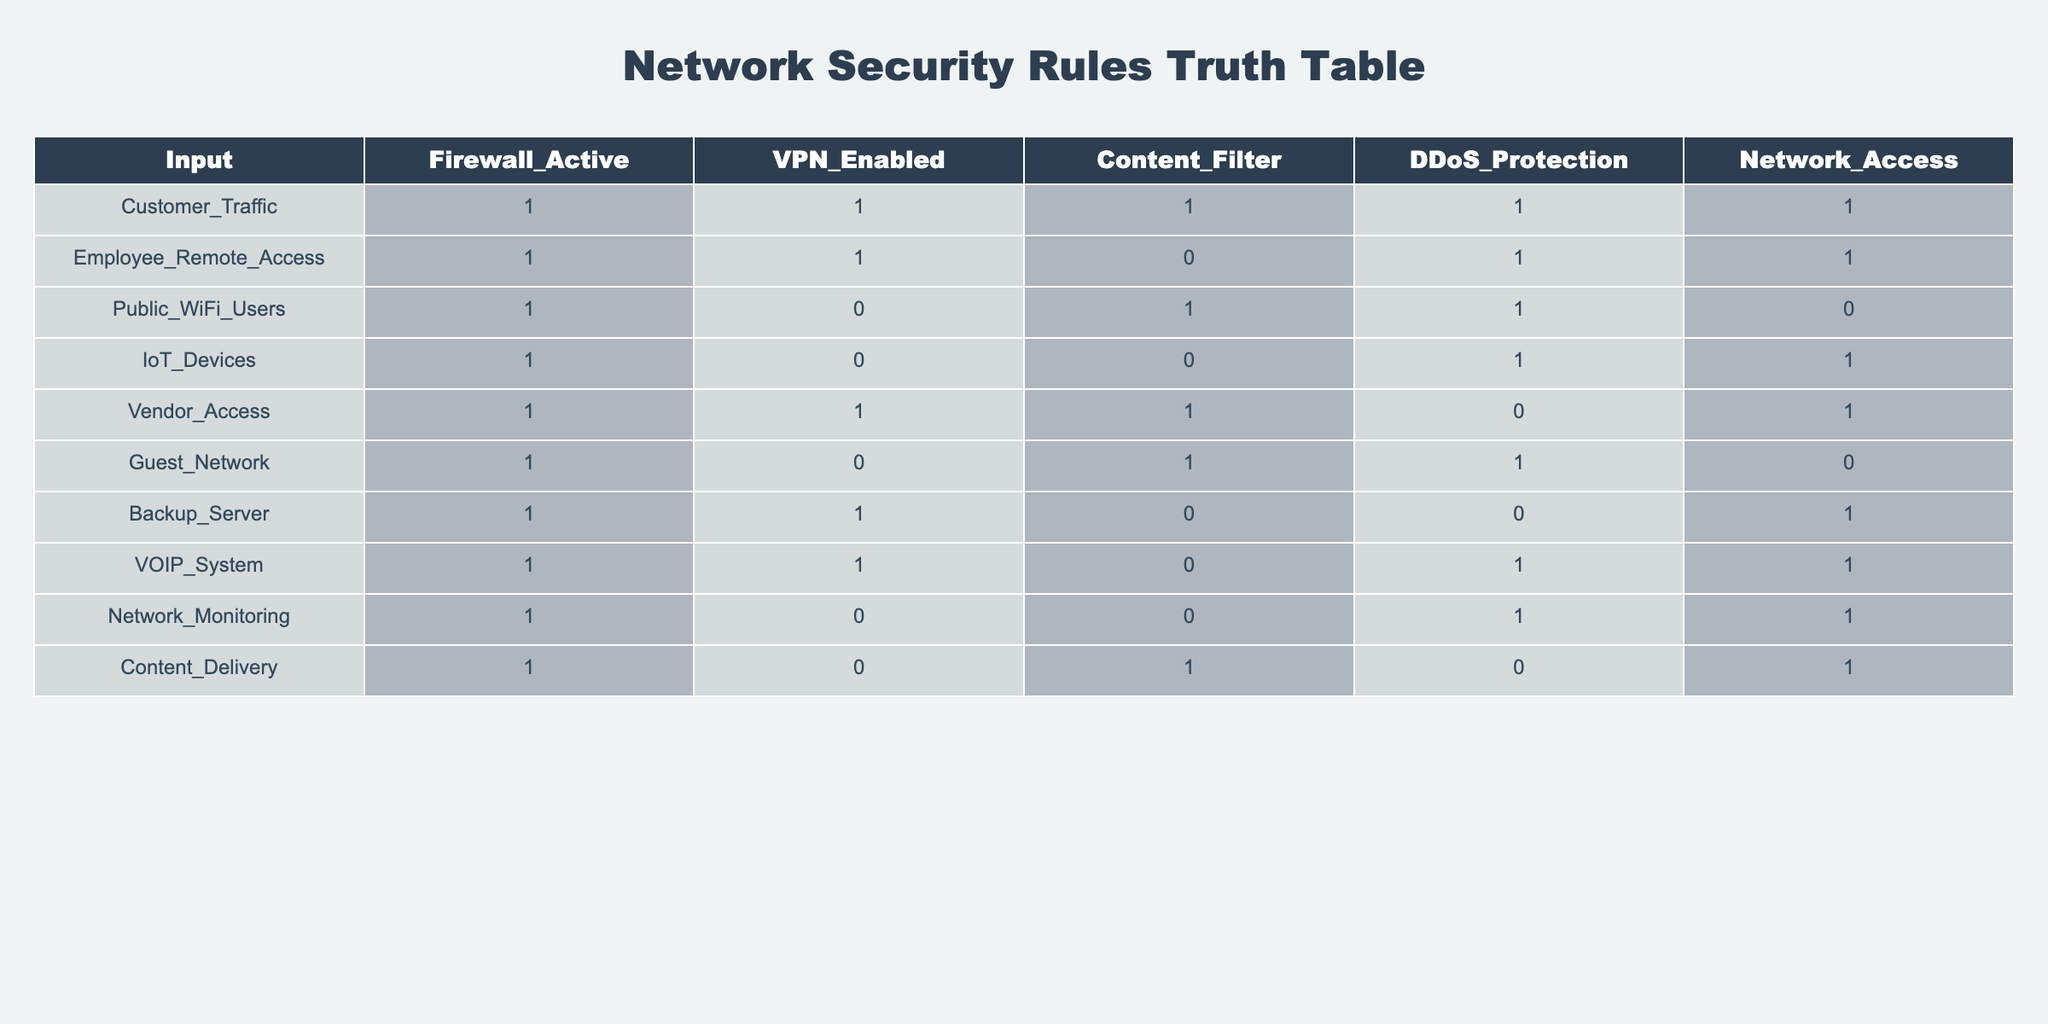What is the status of VPN for Customer Traffic? In the row for Customer Traffic, the value under the VPN_Enabled column is 1, indicating that VPN is enabled for this type of traffic.
Answer: Yes Is DDoS Protection active for IoT Devices? For the row pertaining to IoT Devices, the DDoS_Protection column shows a 1, meaning that DDoS Protection is indeed active for IoT Devices.
Answer: Yes Which category has both VPN and Content Filter enabled? We need to check both the VPN_Enabled and Content_Filter columns for each row. The only row where both are 1 is for Vendor_Access.
Answer: Vendor Access Count how many categories have Network Access disabled. We will look through the Network_Access column and count the occurrences of 0. The relevant rows are Public_WiFi_Users, Guest_Network, and Content_Delivery, giving us a total of 3.
Answer: 3 Is there any category that has Firewall Active but does not have Content Filter enabled? To find this, we check rows with Firewall_Active as 1 and see which ones have Content_Filter as 0. These are Employee_Remote_Access, IoT_Devices, Backup_Server, and Vendor_Access. Since there are valid cases, the answer is yes.
Answer: Yes Identify the category that has all security measures but lacks DDoS Protection. We inspect all categories with DDoS_Protection as 0, then check to see if they satisfy all other conditions. The row for Backup_Server has all other measures enabled except DDoS Protection (0).
Answer: Backup Server What is the difference in count between categories having VPN enabled and those not enabled? Categories with VPN_ENABLED are: Customer_Traffic, Employee_Remote_Access, Vendor_Access, and VOIP_System (4 total). Categories not having VPN enabled are: Public_WiFi_Users, IoT_Devices, Guest_Network, Network_Monitoring, and Content_Delivery (5 total). Therefore, the difference is 4 - 5 = -1.
Answer: -1 Has DDoS Protection been applied to all categories? We look across all rows in the DDoS_Protection column and find that Backup_Server and Vendor_Access are the two that are not using DDoS protection, so the answer is no.
Answer: No Which category has VPN disabled and access granted for public WiFi users? We find that Public_WiFi_Users has VPN_Enabled as 0 while Network_Access is 0 as well, indicating no access granted. The same is true for Guest_Network. So there are no categories that fulfill the condition.
Answer: None 